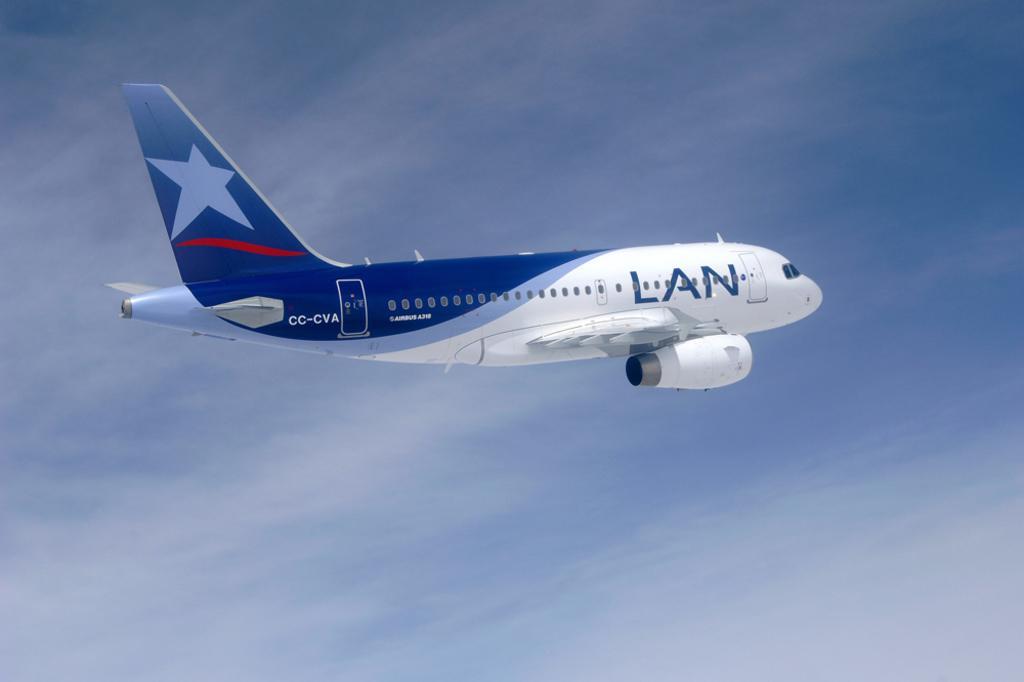How would you summarize this image in a sentence or two? This picture is clicked outside. In the center we can see an airplane flying in the sky and we can see the text on the airplane. In the background we can see the sky. 